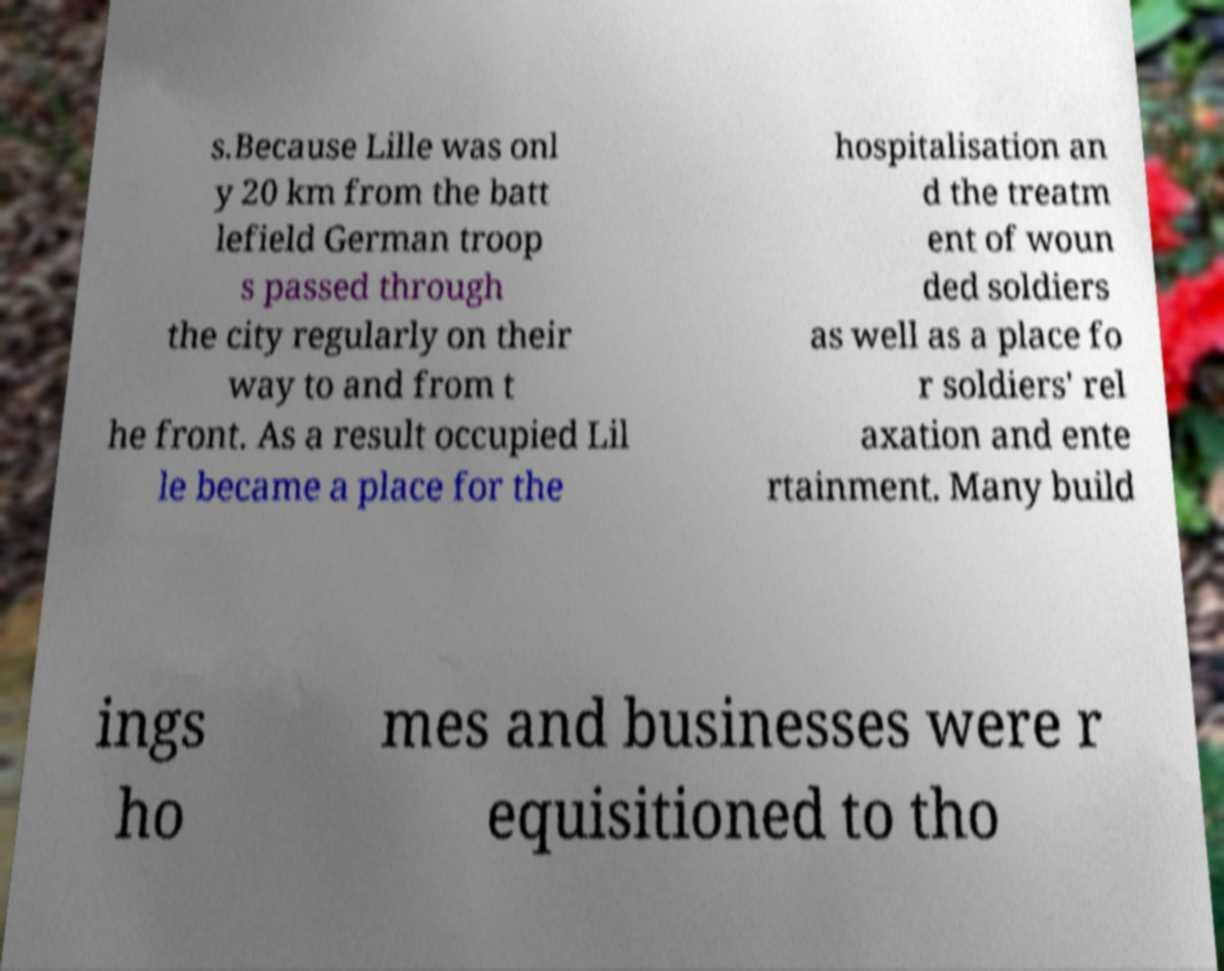What messages or text are displayed in this image? I need them in a readable, typed format. s.Because Lille was onl y 20 km from the batt lefield German troop s passed through the city regularly on their way to and from t he front. As a result occupied Lil le became a place for the hospitalisation an d the treatm ent of woun ded soldiers as well as a place fo r soldiers' rel axation and ente rtainment. Many build ings ho mes and businesses were r equisitioned to tho 